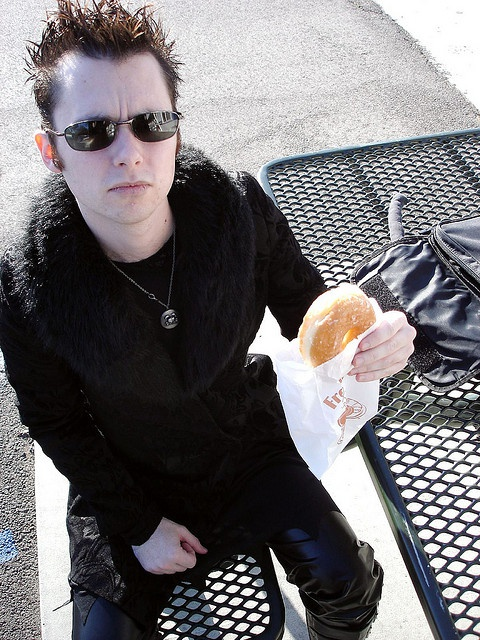Describe the objects in this image and their specific colors. I can see people in lightgray, black, darkgray, and gray tones, dining table in lightgray, white, black, gray, and darkgray tones, handbag in lightgray, black, gray, and darkgray tones, bench in lightgray, black, white, gray, and darkgray tones, and donut in lightgray, ivory, and tan tones in this image. 